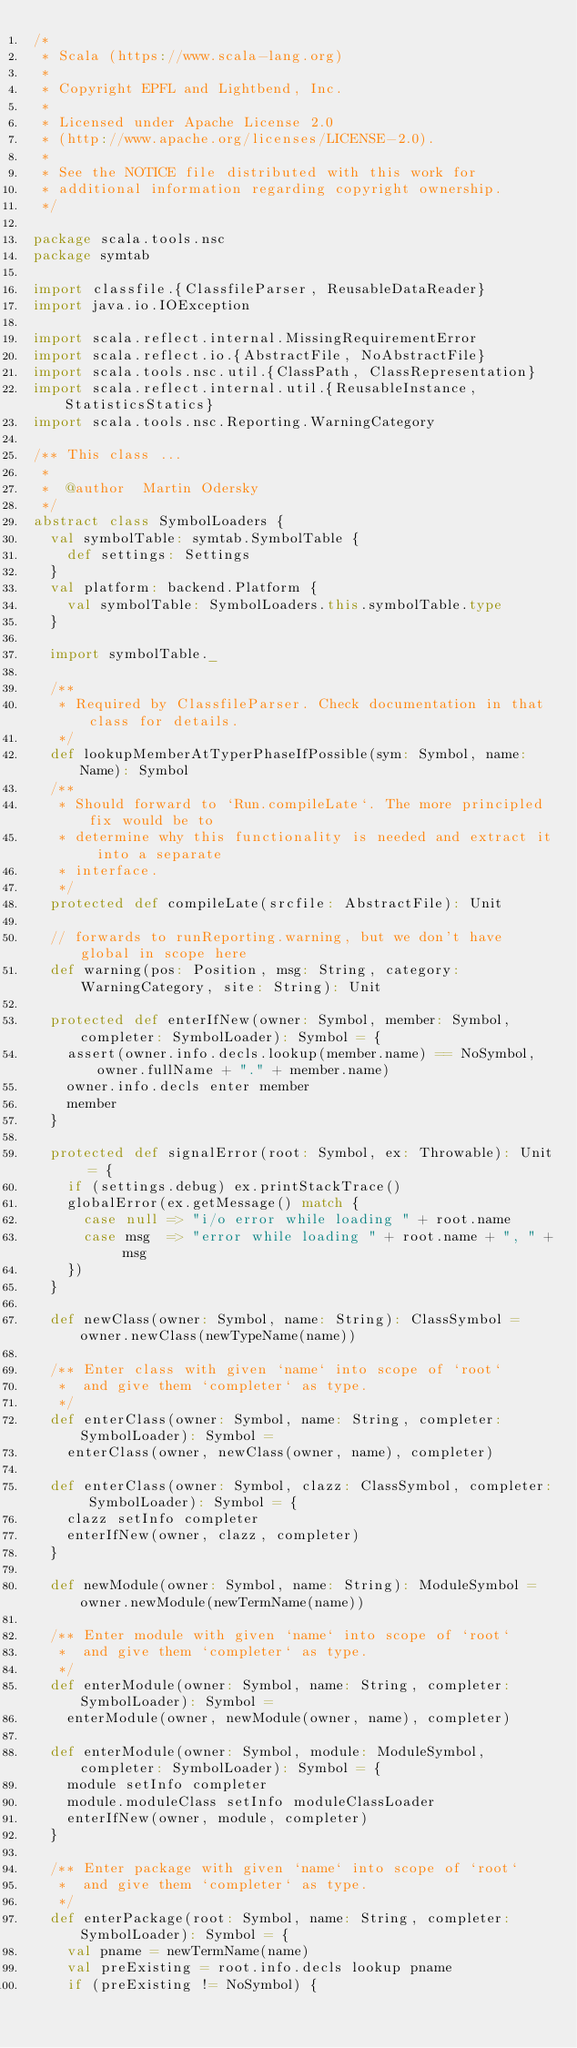Convert code to text. <code><loc_0><loc_0><loc_500><loc_500><_Scala_>/*
 * Scala (https://www.scala-lang.org)
 *
 * Copyright EPFL and Lightbend, Inc.
 *
 * Licensed under Apache License 2.0
 * (http://www.apache.org/licenses/LICENSE-2.0).
 *
 * See the NOTICE file distributed with this work for
 * additional information regarding copyright ownership.
 */

package scala.tools.nsc
package symtab

import classfile.{ClassfileParser, ReusableDataReader}
import java.io.IOException

import scala.reflect.internal.MissingRequirementError
import scala.reflect.io.{AbstractFile, NoAbstractFile}
import scala.tools.nsc.util.{ClassPath, ClassRepresentation}
import scala.reflect.internal.util.{ReusableInstance, StatisticsStatics}
import scala.tools.nsc.Reporting.WarningCategory

/** This class ...
 *
 *  @author  Martin Odersky
 */
abstract class SymbolLoaders {
  val symbolTable: symtab.SymbolTable {
    def settings: Settings
  }
  val platform: backend.Platform {
    val symbolTable: SymbolLoaders.this.symbolTable.type
  }

  import symbolTable._

  /**
   * Required by ClassfileParser. Check documentation in that class for details.
   */
  def lookupMemberAtTyperPhaseIfPossible(sym: Symbol, name: Name): Symbol
  /**
   * Should forward to `Run.compileLate`. The more principled fix would be to
   * determine why this functionality is needed and extract it into a separate
   * interface.
   */
  protected def compileLate(srcfile: AbstractFile): Unit

  // forwards to runReporting.warning, but we don't have global in scope here
  def warning(pos: Position, msg: String, category: WarningCategory, site: String): Unit

  protected def enterIfNew(owner: Symbol, member: Symbol, completer: SymbolLoader): Symbol = {
    assert(owner.info.decls.lookup(member.name) == NoSymbol, owner.fullName + "." + member.name)
    owner.info.decls enter member
    member
  }

  protected def signalError(root: Symbol, ex: Throwable): Unit = {
    if (settings.debug) ex.printStackTrace()
    globalError(ex.getMessage() match {
      case null => "i/o error while loading " + root.name
      case msg  => "error while loading " + root.name + ", " + msg
    })
  }

  def newClass(owner: Symbol, name: String): ClassSymbol = owner.newClass(newTypeName(name))

  /** Enter class with given `name` into scope of `root`
   *  and give them `completer` as type.
   */
  def enterClass(owner: Symbol, name: String, completer: SymbolLoader): Symbol =
    enterClass(owner, newClass(owner, name), completer)

  def enterClass(owner: Symbol, clazz: ClassSymbol, completer: SymbolLoader): Symbol = {
    clazz setInfo completer
    enterIfNew(owner, clazz, completer)
  }

  def newModule(owner: Symbol, name: String): ModuleSymbol = owner.newModule(newTermName(name))

  /** Enter module with given `name` into scope of `root`
   *  and give them `completer` as type.
   */
  def enterModule(owner: Symbol, name: String, completer: SymbolLoader): Symbol =
    enterModule(owner, newModule(owner, name), completer)

  def enterModule(owner: Symbol, module: ModuleSymbol, completer: SymbolLoader): Symbol = {
    module setInfo completer
    module.moduleClass setInfo moduleClassLoader
    enterIfNew(owner, module, completer)
  }

  /** Enter package with given `name` into scope of `root`
   *  and give them `completer` as type.
   */
  def enterPackage(root: Symbol, name: String, completer: SymbolLoader): Symbol = {
    val pname = newTermName(name)
    val preExisting = root.info.decls lookup pname
    if (preExisting != NoSymbol) {</code> 